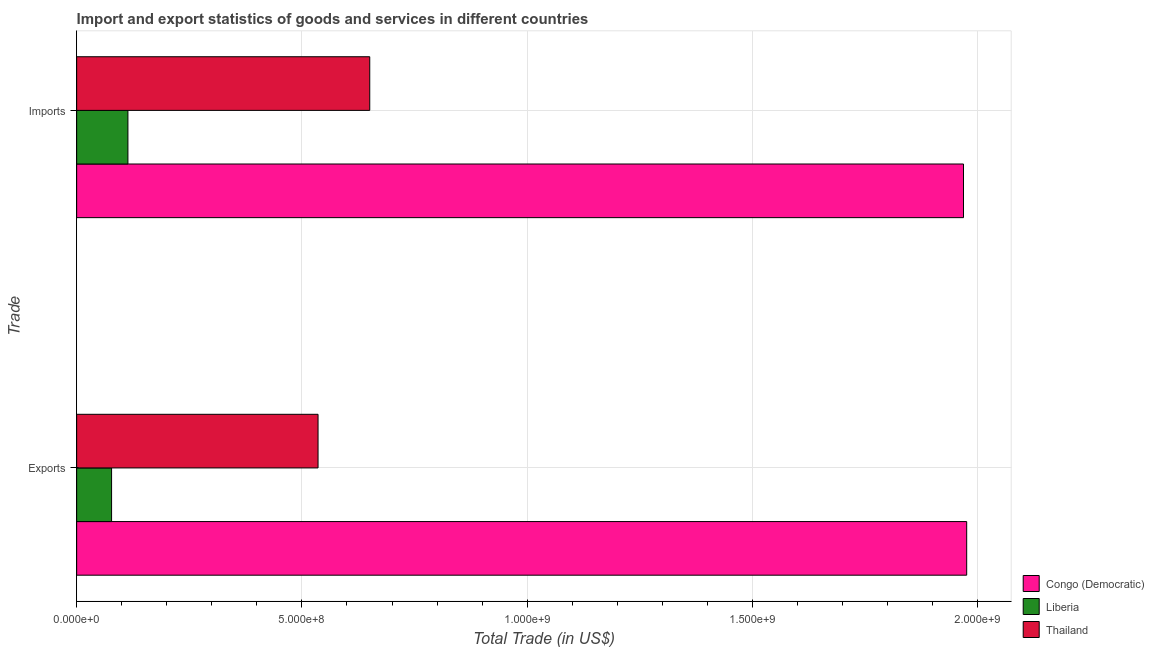How many different coloured bars are there?
Provide a succinct answer. 3. Are the number of bars on each tick of the Y-axis equal?
Provide a succinct answer. Yes. How many bars are there on the 2nd tick from the top?
Your answer should be very brief. 3. What is the label of the 1st group of bars from the top?
Provide a succinct answer. Imports. What is the imports of goods and services in Congo (Democratic)?
Offer a terse response. 1.97e+09. Across all countries, what is the maximum export of goods and services?
Make the answer very short. 1.98e+09. Across all countries, what is the minimum imports of goods and services?
Offer a very short reply. 1.14e+08. In which country was the export of goods and services maximum?
Offer a terse response. Congo (Democratic). In which country was the imports of goods and services minimum?
Keep it short and to the point. Liberia. What is the total imports of goods and services in the graph?
Make the answer very short. 2.73e+09. What is the difference between the export of goods and services in Thailand and that in Liberia?
Your answer should be compact. 4.58e+08. What is the difference between the imports of goods and services in Congo (Democratic) and the export of goods and services in Liberia?
Provide a short and direct response. 1.89e+09. What is the average export of goods and services per country?
Keep it short and to the point. 8.63e+08. What is the difference between the export of goods and services and imports of goods and services in Congo (Democratic)?
Your response must be concise. 7.08e+06. In how many countries, is the imports of goods and services greater than 1100000000 US$?
Provide a short and direct response. 1. What is the ratio of the export of goods and services in Congo (Democratic) to that in Liberia?
Offer a very short reply. 25.49. In how many countries, is the export of goods and services greater than the average export of goods and services taken over all countries?
Your answer should be very brief. 1. What does the 2nd bar from the top in Exports represents?
Give a very brief answer. Liberia. What does the 3rd bar from the bottom in Imports represents?
Provide a short and direct response. Thailand. Are all the bars in the graph horizontal?
Make the answer very short. Yes. How many countries are there in the graph?
Ensure brevity in your answer.  3. What is the difference between two consecutive major ticks on the X-axis?
Your answer should be compact. 5.00e+08. Are the values on the major ticks of X-axis written in scientific E-notation?
Offer a very short reply. Yes. Does the graph contain grids?
Make the answer very short. Yes. How many legend labels are there?
Offer a very short reply. 3. What is the title of the graph?
Offer a very short reply. Import and export statistics of goods and services in different countries. Does "San Marino" appear as one of the legend labels in the graph?
Your answer should be very brief. No. What is the label or title of the X-axis?
Offer a terse response. Total Trade (in US$). What is the label or title of the Y-axis?
Make the answer very short. Trade. What is the Total Trade (in US$) of Congo (Democratic) in Exports?
Keep it short and to the point. 1.98e+09. What is the Total Trade (in US$) of Liberia in Exports?
Your answer should be compact. 7.75e+07. What is the Total Trade (in US$) of Thailand in Exports?
Your answer should be compact. 5.36e+08. What is the Total Trade (in US$) of Congo (Democratic) in Imports?
Your response must be concise. 1.97e+09. What is the Total Trade (in US$) in Liberia in Imports?
Offer a very short reply. 1.14e+08. What is the Total Trade (in US$) of Thailand in Imports?
Provide a succinct answer. 6.51e+08. Across all Trade, what is the maximum Total Trade (in US$) of Congo (Democratic)?
Your response must be concise. 1.98e+09. Across all Trade, what is the maximum Total Trade (in US$) of Liberia?
Offer a very short reply. 1.14e+08. Across all Trade, what is the maximum Total Trade (in US$) of Thailand?
Provide a short and direct response. 6.51e+08. Across all Trade, what is the minimum Total Trade (in US$) of Congo (Democratic)?
Ensure brevity in your answer.  1.97e+09. Across all Trade, what is the minimum Total Trade (in US$) of Liberia?
Provide a short and direct response. 7.75e+07. Across all Trade, what is the minimum Total Trade (in US$) of Thailand?
Your answer should be very brief. 5.36e+08. What is the total Total Trade (in US$) of Congo (Democratic) in the graph?
Provide a succinct answer. 3.94e+09. What is the total Total Trade (in US$) in Liberia in the graph?
Offer a very short reply. 1.91e+08. What is the total Total Trade (in US$) of Thailand in the graph?
Provide a succinct answer. 1.19e+09. What is the difference between the Total Trade (in US$) in Congo (Democratic) in Exports and that in Imports?
Provide a short and direct response. 7.08e+06. What is the difference between the Total Trade (in US$) of Liberia in Exports and that in Imports?
Provide a succinct answer. -3.63e+07. What is the difference between the Total Trade (in US$) in Thailand in Exports and that in Imports?
Keep it short and to the point. -1.15e+08. What is the difference between the Total Trade (in US$) in Congo (Democratic) in Exports and the Total Trade (in US$) in Liberia in Imports?
Provide a succinct answer. 1.86e+09. What is the difference between the Total Trade (in US$) in Congo (Democratic) in Exports and the Total Trade (in US$) in Thailand in Imports?
Give a very brief answer. 1.33e+09. What is the difference between the Total Trade (in US$) of Liberia in Exports and the Total Trade (in US$) of Thailand in Imports?
Offer a terse response. -5.73e+08. What is the average Total Trade (in US$) of Congo (Democratic) per Trade?
Your response must be concise. 1.97e+09. What is the average Total Trade (in US$) of Liberia per Trade?
Offer a very short reply. 9.56e+07. What is the average Total Trade (in US$) in Thailand per Trade?
Provide a short and direct response. 5.93e+08. What is the difference between the Total Trade (in US$) in Congo (Democratic) and Total Trade (in US$) in Liberia in Exports?
Keep it short and to the point. 1.90e+09. What is the difference between the Total Trade (in US$) in Congo (Democratic) and Total Trade (in US$) in Thailand in Exports?
Make the answer very short. 1.44e+09. What is the difference between the Total Trade (in US$) of Liberia and Total Trade (in US$) of Thailand in Exports?
Provide a succinct answer. -4.58e+08. What is the difference between the Total Trade (in US$) of Congo (Democratic) and Total Trade (in US$) of Liberia in Imports?
Offer a terse response. 1.85e+09. What is the difference between the Total Trade (in US$) in Congo (Democratic) and Total Trade (in US$) in Thailand in Imports?
Ensure brevity in your answer.  1.32e+09. What is the difference between the Total Trade (in US$) of Liberia and Total Trade (in US$) of Thailand in Imports?
Make the answer very short. -5.37e+08. What is the ratio of the Total Trade (in US$) of Liberia in Exports to that in Imports?
Your answer should be compact. 0.68. What is the ratio of the Total Trade (in US$) of Thailand in Exports to that in Imports?
Your answer should be very brief. 0.82. What is the difference between the highest and the second highest Total Trade (in US$) of Congo (Democratic)?
Offer a terse response. 7.08e+06. What is the difference between the highest and the second highest Total Trade (in US$) of Liberia?
Keep it short and to the point. 3.63e+07. What is the difference between the highest and the second highest Total Trade (in US$) in Thailand?
Ensure brevity in your answer.  1.15e+08. What is the difference between the highest and the lowest Total Trade (in US$) of Congo (Democratic)?
Ensure brevity in your answer.  7.08e+06. What is the difference between the highest and the lowest Total Trade (in US$) in Liberia?
Provide a succinct answer. 3.63e+07. What is the difference between the highest and the lowest Total Trade (in US$) in Thailand?
Your response must be concise. 1.15e+08. 